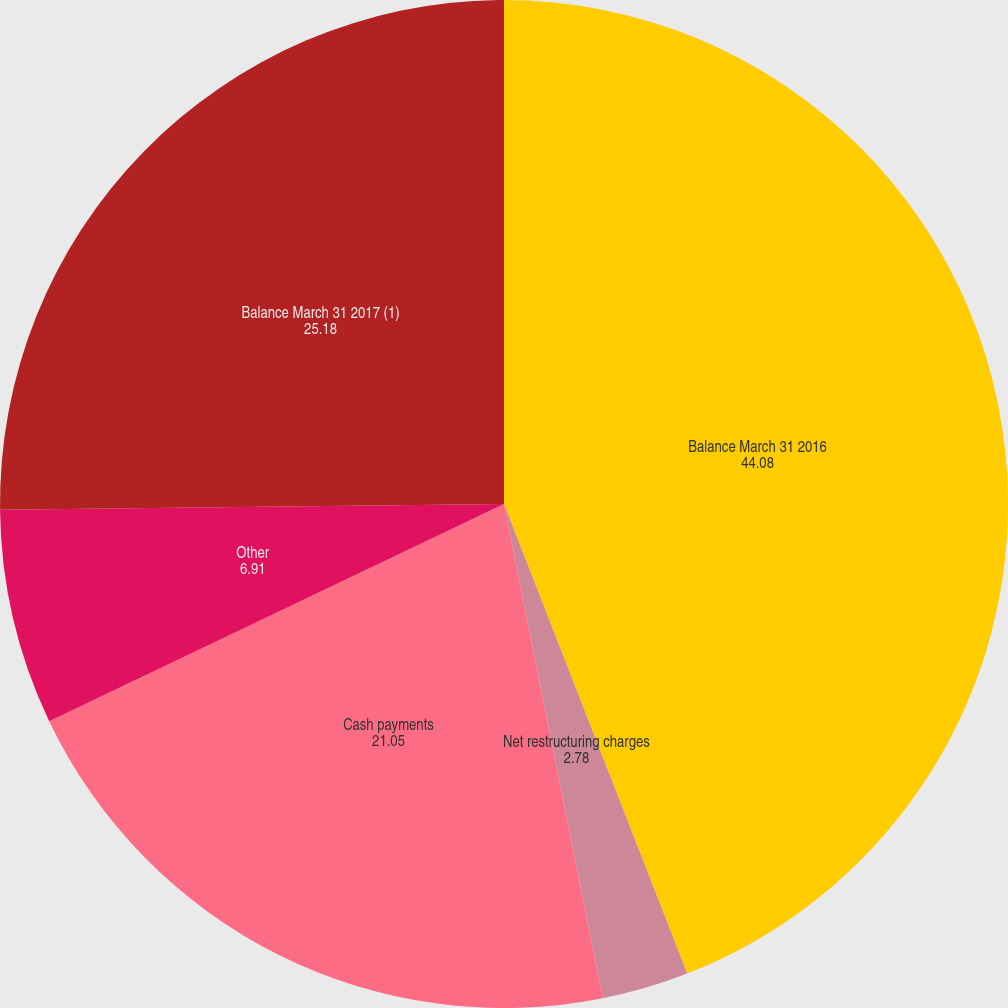<chart> <loc_0><loc_0><loc_500><loc_500><pie_chart><fcel>Balance March 31 2016<fcel>Net restructuring charges<fcel>Cash payments<fcel>Other<fcel>Balance March 31 2017 (1)<nl><fcel>44.08%<fcel>2.78%<fcel>21.05%<fcel>6.91%<fcel>25.18%<nl></chart> 